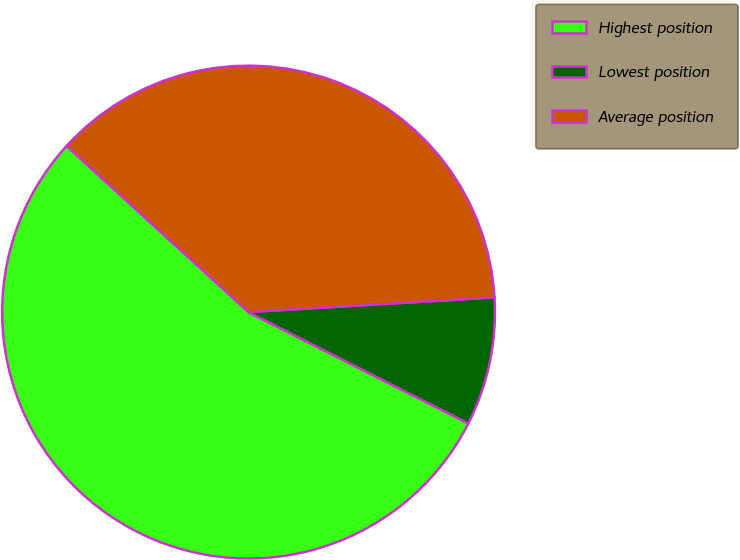Convert chart. <chart><loc_0><loc_0><loc_500><loc_500><pie_chart><fcel>Highest position<fcel>Lowest position<fcel>Average position<nl><fcel>54.32%<fcel>8.41%<fcel>37.27%<nl></chart> 